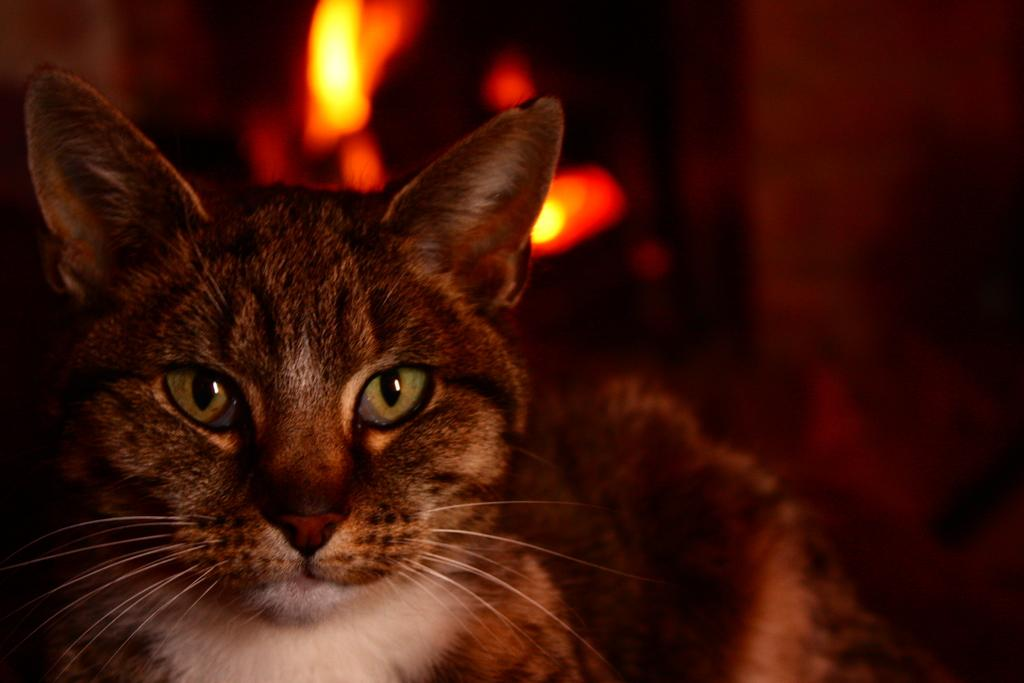What animal is present in the image? There is a cat in the picture. Can you describe the background of the image? The background of the cat is blurred. What type of experience does the squirrel have in the image? There is no squirrel present in the image, so it is not possible to determine any experiences related to a squirrel. 